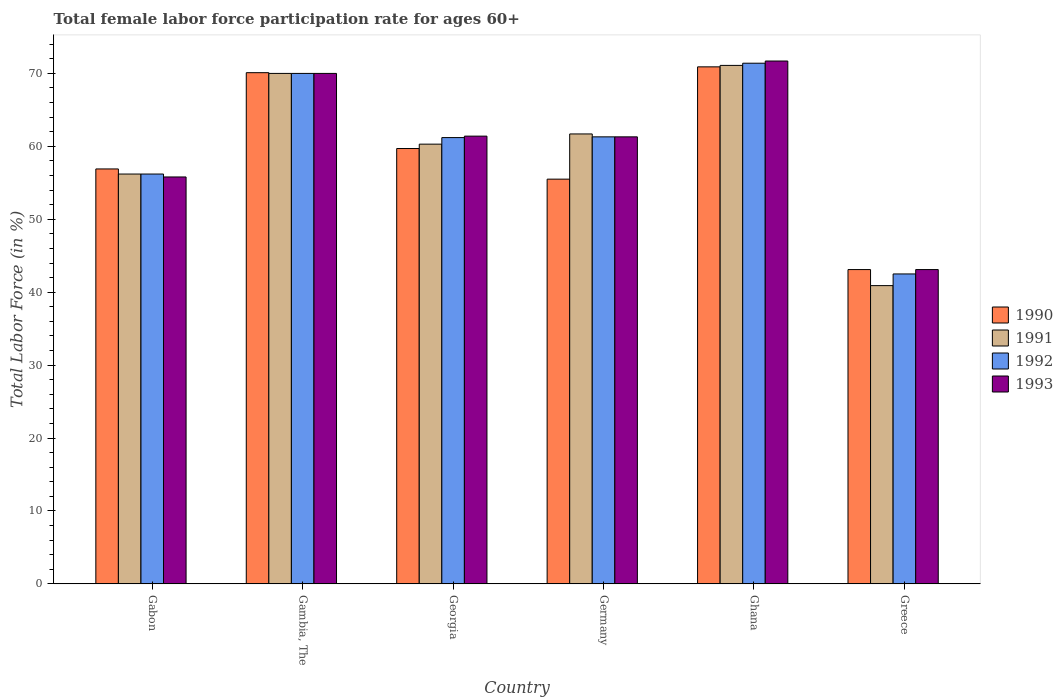How many different coloured bars are there?
Ensure brevity in your answer.  4. How many groups of bars are there?
Offer a very short reply. 6. How many bars are there on the 5th tick from the right?
Your answer should be compact. 4. What is the label of the 3rd group of bars from the left?
Your answer should be very brief. Georgia. In how many cases, is the number of bars for a given country not equal to the number of legend labels?
Your answer should be compact. 0. What is the female labor force participation rate in 1992 in Greece?
Make the answer very short. 42.5. Across all countries, what is the maximum female labor force participation rate in 1992?
Your answer should be compact. 71.4. Across all countries, what is the minimum female labor force participation rate in 1993?
Offer a terse response. 43.1. In which country was the female labor force participation rate in 1991 maximum?
Make the answer very short. Ghana. What is the total female labor force participation rate in 1991 in the graph?
Your answer should be compact. 360.2. What is the difference between the female labor force participation rate in 1993 in Gambia, The and that in Ghana?
Offer a very short reply. -1.7. What is the difference between the female labor force participation rate in 1992 in Germany and the female labor force participation rate in 1990 in Greece?
Your answer should be compact. 18.2. What is the average female labor force participation rate in 1990 per country?
Your response must be concise. 59.37. What is the difference between the female labor force participation rate of/in 1993 and female labor force participation rate of/in 1990 in Germany?
Your answer should be very brief. 5.8. What is the ratio of the female labor force participation rate in 1990 in Germany to that in Greece?
Provide a succinct answer. 1.29. Is the female labor force participation rate in 1990 in Georgia less than that in Greece?
Your answer should be compact. No. Is the difference between the female labor force participation rate in 1993 in Georgia and Greece greater than the difference between the female labor force participation rate in 1990 in Georgia and Greece?
Give a very brief answer. Yes. What is the difference between the highest and the second highest female labor force participation rate in 1991?
Provide a succinct answer. -8.3. What is the difference between the highest and the lowest female labor force participation rate in 1991?
Offer a very short reply. 30.2. Is the sum of the female labor force participation rate in 1993 in Gabon and Gambia, The greater than the maximum female labor force participation rate in 1990 across all countries?
Your answer should be compact. Yes. Is it the case that in every country, the sum of the female labor force participation rate in 1990 and female labor force participation rate in 1993 is greater than the sum of female labor force participation rate in 1992 and female labor force participation rate in 1991?
Provide a succinct answer. No. What does the 4th bar from the right in Gambia, The represents?
Keep it short and to the point. 1990. Is it the case that in every country, the sum of the female labor force participation rate in 1991 and female labor force participation rate in 1993 is greater than the female labor force participation rate in 1992?
Offer a terse response. Yes. What is the difference between two consecutive major ticks on the Y-axis?
Keep it short and to the point. 10. Does the graph contain grids?
Make the answer very short. No. Where does the legend appear in the graph?
Your answer should be very brief. Center right. What is the title of the graph?
Offer a terse response. Total female labor force participation rate for ages 60+. Does "2008" appear as one of the legend labels in the graph?
Your response must be concise. No. What is the label or title of the X-axis?
Keep it short and to the point. Country. What is the label or title of the Y-axis?
Give a very brief answer. Total Labor Force (in %). What is the Total Labor Force (in %) in 1990 in Gabon?
Keep it short and to the point. 56.9. What is the Total Labor Force (in %) in 1991 in Gabon?
Provide a succinct answer. 56.2. What is the Total Labor Force (in %) in 1992 in Gabon?
Offer a terse response. 56.2. What is the Total Labor Force (in %) in 1993 in Gabon?
Your response must be concise. 55.8. What is the Total Labor Force (in %) in 1990 in Gambia, The?
Ensure brevity in your answer.  70.1. What is the Total Labor Force (in %) of 1992 in Gambia, The?
Ensure brevity in your answer.  70. What is the Total Labor Force (in %) of 1990 in Georgia?
Your answer should be compact. 59.7. What is the Total Labor Force (in %) of 1991 in Georgia?
Your answer should be compact. 60.3. What is the Total Labor Force (in %) of 1992 in Georgia?
Your answer should be very brief. 61.2. What is the Total Labor Force (in %) of 1993 in Georgia?
Keep it short and to the point. 61.4. What is the Total Labor Force (in %) in 1990 in Germany?
Provide a succinct answer. 55.5. What is the Total Labor Force (in %) of 1991 in Germany?
Your answer should be very brief. 61.7. What is the Total Labor Force (in %) in 1992 in Germany?
Ensure brevity in your answer.  61.3. What is the Total Labor Force (in %) in 1993 in Germany?
Make the answer very short. 61.3. What is the Total Labor Force (in %) in 1990 in Ghana?
Provide a short and direct response. 70.9. What is the Total Labor Force (in %) in 1991 in Ghana?
Your response must be concise. 71.1. What is the Total Labor Force (in %) in 1992 in Ghana?
Keep it short and to the point. 71.4. What is the Total Labor Force (in %) in 1993 in Ghana?
Your answer should be compact. 71.7. What is the Total Labor Force (in %) in 1990 in Greece?
Offer a terse response. 43.1. What is the Total Labor Force (in %) of 1991 in Greece?
Your answer should be compact. 40.9. What is the Total Labor Force (in %) in 1992 in Greece?
Your answer should be very brief. 42.5. What is the Total Labor Force (in %) of 1993 in Greece?
Your response must be concise. 43.1. Across all countries, what is the maximum Total Labor Force (in %) of 1990?
Your answer should be compact. 70.9. Across all countries, what is the maximum Total Labor Force (in %) in 1991?
Your response must be concise. 71.1. Across all countries, what is the maximum Total Labor Force (in %) of 1992?
Keep it short and to the point. 71.4. Across all countries, what is the maximum Total Labor Force (in %) of 1993?
Give a very brief answer. 71.7. Across all countries, what is the minimum Total Labor Force (in %) of 1990?
Your answer should be very brief. 43.1. Across all countries, what is the minimum Total Labor Force (in %) in 1991?
Your answer should be compact. 40.9. Across all countries, what is the minimum Total Labor Force (in %) of 1992?
Provide a short and direct response. 42.5. Across all countries, what is the minimum Total Labor Force (in %) in 1993?
Offer a very short reply. 43.1. What is the total Total Labor Force (in %) of 1990 in the graph?
Make the answer very short. 356.2. What is the total Total Labor Force (in %) of 1991 in the graph?
Offer a very short reply. 360.2. What is the total Total Labor Force (in %) of 1992 in the graph?
Offer a terse response. 362.6. What is the total Total Labor Force (in %) of 1993 in the graph?
Your response must be concise. 363.3. What is the difference between the Total Labor Force (in %) in 1991 in Gabon and that in Georgia?
Keep it short and to the point. -4.1. What is the difference between the Total Labor Force (in %) in 1992 in Gabon and that in Georgia?
Provide a succinct answer. -5. What is the difference between the Total Labor Force (in %) in 1993 in Gabon and that in Georgia?
Make the answer very short. -5.6. What is the difference between the Total Labor Force (in %) of 1990 in Gabon and that in Ghana?
Your answer should be very brief. -14. What is the difference between the Total Labor Force (in %) of 1991 in Gabon and that in Ghana?
Provide a succinct answer. -14.9. What is the difference between the Total Labor Force (in %) of 1992 in Gabon and that in Ghana?
Your answer should be compact. -15.2. What is the difference between the Total Labor Force (in %) in 1993 in Gabon and that in Ghana?
Give a very brief answer. -15.9. What is the difference between the Total Labor Force (in %) of 1991 in Gabon and that in Greece?
Make the answer very short. 15.3. What is the difference between the Total Labor Force (in %) of 1993 in Gabon and that in Greece?
Your answer should be compact. 12.7. What is the difference between the Total Labor Force (in %) in 1990 in Gambia, The and that in Georgia?
Ensure brevity in your answer.  10.4. What is the difference between the Total Labor Force (in %) of 1991 in Gambia, The and that in Georgia?
Your answer should be compact. 9.7. What is the difference between the Total Labor Force (in %) in 1993 in Gambia, The and that in Georgia?
Offer a terse response. 8.6. What is the difference between the Total Labor Force (in %) of 1990 in Gambia, The and that in Germany?
Your answer should be compact. 14.6. What is the difference between the Total Labor Force (in %) in 1991 in Gambia, The and that in Germany?
Make the answer very short. 8.3. What is the difference between the Total Labor Force (in %) in 1992 in Gambia, The and that in Germany?
Make the answer very short. 8.7. What is the difference between the Total Labor Force (in %) of 1993 in Gambia, The and that in Germany?
Ensure brevity in your answer.  8.7. What is the difference between the Total Labor Force (in %) in 1990 in Gambia, The and that in Ghana?
Your answer should be very brief. -0.8. What is the difference between the Total Labor Force (in %) in 1992 in Gambia, The and that in Ghana?
Offer a very short reply. -1.4. What is the difference between the Total Labor Force (in %) of 1990 in Gambia, The and that in Greece?
Make the answer very short. 27. What is the difference between the Total Labor Force (in %) in 1991 in Gambia, The and that in Greece?
Keep it short and to the point. 29.1. What is the difference between the Total Labor Force (in %) in 1992 in Gambia, The and that in Greece?
Your response must be concise. 27.5. What is the difference between the Total Labor Force (in %) in 1993 in Gambia, The and that in Greece?
Keep it short and to the point. 26.9. What is the difference between the Total Labor Force (in %) in 1992 in Georgia and that in Germany?
Keep it short and to the point. -0.1. What is the difference between the Total Labor Force (in %) in 1990 in Georgia and that in Ghana?
Ensure brevity in your answer.  -11.2. What is the difference between the Total Labor Force (in %) of 1993 in Georgia and that in Ghana?
Provide a succinct answer. -10.3. What is the difference between the Total Labor Force (in %) of 1990 in Georgia and that in Greece?
Ensure brevity in your answer.  16.6. What is the difference between the Total Labor Force (in %) in 1992 in Georgia and that in Greece?
Your answer should be compact. 18.7. What is the difference between the Total Labor Force (in %) in 1993 in Georgia and that in Greece?
Give a very brief answer. 18.3. What is the difference between the Total Labor Force (in %) in 1990 in Germany and that in Ghana?
Provide a short and direct response. -15.4. What is the difference between the Total Labor Force (in %) of 1991 in Germany and that in Ghana?
Offer a very short reply. -9.4. What is the difference between the Total Labor Force (in %) in 1993 in Germany and that in Ghana?
Your answer should be very brief. -10.4. What is the difference between the Total Labor Force (in %) of 1991 in Germany and that in Greece?
Make the answer very short. 20.8. What is the difference between the Total Labor Force (in %) in 1992 in Germany and that in Greece?
Make the answer very short. 18.8. What is the difference between the Total Labor Force (in %) of 1990 in Ghana and that in Greece?
Ensure brevity in your answer.  27.8. What is the difference between the Total Labor Force (in %) in 1991 in Ghana and that in Greece?
Make the answer very short. 30.2. What is the difference between the Total Labor Force (in %) of 1992 in Ghana and that in Greece?
Provide a short and direct response. 28.9. What is the difference between the Total Labor Force (in %) in 1993 in Ghana and that in Greece?
Your answer should be compact. 28.6. What is the difference between the Total Labor Force (in %) of 1990 in Gabon and the Total Labor Force (in %) of 1991 in Gambia, The?
Keep it short and to the point. -13.1. What is the difference between the Total Labor Force (in %) of 1990 in Gabon and the Total Labor Force (in %) of 1992 in Gambia, The?
Your answer should be very brief. -13.1. What is the difference between the Total Labor Force (in %) in 1990 in Gabon and the Total Labor Force (in %) in 1993 in Gambia, The?
Offer a terse response. -13.1. What is the difference between the Total Labor Force (in %) of 1991 in Gabon and the Total Labor Force (in %) of 1993 in Gambia, The?
Keep it short and to the point. -13.8. What is the difference between the Total Labor Force (in %) of 1990 in Gabon and the Total Labor Force (in %) of 1991 in Georgia?
Make the answer very short. -3.4. What is the difference between the Total Labor Force (in %) in 1990 in Gabon and the Total Labor Force (in %) in 1993 in Georgia?
Give a very brief answer. -4.5. What is the difference between the Total Labor Force (in %) in 1991 in Gabon and the Total Labor Force (in %) in 1992 in Georgia?
Offer a terse response. -5. What is the difference between the Total Labor Force (in %) in 1990 in Gabon and the Total Labor Force (in %) in 1992 in Germany?
Your answer should be very brief. -4.4. What is the difference between the Total Labor Force (in %) of 1991 in Gabon and the Total Labor Force (in %) of 1992 in Germany?
Offer a very short reply. -5.1. What is the difference between the Total Labor Force (in %) of 1991 in Gabon and the Total Labor Force (in %) of 1993 in Germany?
Offer a terse response. -5.1. What is the difference between the Total Labor Force (in %) in 1992 in Gabon and the Total Labor Force (in %) in 1993 in Germany?
Provide a short and direct response. -5.1. What is the difference between the Total Labor Force (in %) in 1990 in Gabon and the Total Labor Force (in %) in 1991 in Ghana?
Your answer should be compact. -14.2. What is the difference between the Total Labor Force (in %) of 1990 in Gabon and the Total Labor Force (in %) of 1992 in Ghana?
Your answer should be compact. -14.5. What is the difference between the Total Labor Force (in %) of 1990 in Gabon and the Total Labor Force (in %) of 1993 in Ghana?
Ensure brevity in your answer.  -14.8. What is the difference between the Total Labor Force (in %) of 1991 in Gabon and the Total Labor Force (in %) of 1992 in Ghana?
Ensure brevity in your answer.  -15.2. What is the difference between the Total Labor Force (in %) in 1991 in Gabon and the Total Labor Force (in %) in 1993 in Ghana?
Your answer should be very brief. -15.5. What is the difference between the Total Labor Force (in %) in 1992 in Gabon and the Total Labor Force (in %) in 1993 in Ghana?
Your answer should be compact. -15.5. What is the difference between the Total Labor Force (in %) of 1990 in Gabon and the Total Labor Force (in %) of 1991 in Greece?
Keep it short and to the point. 16. What is the difference between the Total Labor Force (in %) of 1990 in Gabon and the Total Labor Force (in %) of 1993 in Greece?
Your answer should be very brief. 13.8. What is the difference between the Total Labor Force (in %) in 1991 in Gabon and the Total Labor Force (in %) in 1992 in Greece?
Provide a succinct answer. 13.7. What is the difference between the Total Labor Force (in %) in 1991 in Gabon and the Total Labor Force (in %) in 1993 in Greece?
Ensure brevity in your answer.  13.1. What is the difference between the Total Labor Force (in %) of 1992 in Gabon and the Total Labor Force (in %) of 1993 in Greece?
Give a very brief answer. 13.1. What is the difference between the Total Labor Force (in %) in 1990 in Gambia, The and the Total Labor Force (in %) in 1992 in Georgia?
Make the answer very short. 8.9. What is the difference between the Total Labor Force (in %) in 1990 in Gambia, The and the Total Labor Force (in %) in 1991 in Germany?
Your answer should be very brief. 8.4. What is the difference between the Total Labor Force (in %) in 1990 in Gambia, The and the Total Labor Force (in %) in 1991 in Ghana?
Give a very brief answer. -1. What is the difference between the Total Labor Force (in %) in 1990 in Gambia, The and the Total Labor Force (in %) in 1992 in Ghana?
Offer a terse response. -1.3. What is the difference between the Total Labor Force (in %) of 1991 in Gambia, The and the Total Labor Force (in %) of 1992 in Ghana?
Keep it short and to the point. -1.4. What is the difference between the Total Labor Force (in %) in 1992 in Gambia, The and the Total Labor Force (in %) in 1993 in Ghana?
Ensure brevity in your answer.  -1.7. What is the difference between the Total Labor Force (in %) of 1990 in Gambia, The and the Total Labor Force (in %) of 1991 in Greece?
Offer a terse response. 29.2. What is the difference between the Total Labor Force (in %) in 1990 in Gambia, The and the Total Labor Force (in %) in 1992 in Greece?
Ensure brevity in your answer.  27.6. What is the difference between the Total Labor Force (in %) in 1991 in Gambia, The and the Total Labor Force (in %) in 1992 in Greece?
Provide a short and direct response. 27.5. What is the difference between the Total Labor Force (in %) of 1991 in Gambia, The and the Total Labor Force (in %) of 1993 in Greece?
Your answer should be compact. 26.9. What is the difference between the Total Labor Force (in %) in 1992 in Gambia, The and the Total Labor Force (in %) in 1993 in Greece?
Provide a succinct answer. 26.9. What is the difference between the Total Labor Force (in %) of 1990 in Georgia and the Total Labor Force (in %) of 1992 in Germany?
Keep it short and to the point. -1.6. What is the difference between the Total Labor Force (in %) in 1990 in Georgia and the Total Labor Force (in %) in 1992 in Ghana?
Make the answer very short. -11.7. What is the difference between the Total Labor Force (in %) in 1990 in Georgia and the Total Labor Force (in %) in 1992 in Greece?
Your answer should be compact. 17.2. What is the difference between the Total Labor Force (in %) in 1991 in Georgia and the Total Labor Force (in %) in 1993 in Greece?
Make the answer very short. 17.2. What is the difference between the Total Labor Force (in %) of 1992 in Georgia and the Total Labor Force (in %) of 1993 in Greece?
Make the answer very short. 18.1. What is the difference between the Total Labor Force (in %) of 1990 in Germany and the Total Labor Force (in %) of 1991 in Ghana?
Your answer should be compact. -15.6. What is the difference between the Total Labor Force (in %) of 1990 in Germany and the Total Labor Force (in %) of 1992 in Ghana?
Make the answer very short. -15.9. What is the difference between the Total Labor Force (in %) of 1990 in Germany and the Total Labor Force (in %) of 1993 in Ghana?
Give a very brief answer. -16.2. What is the difference between the Total Labor Force (in %) of 1991 in Germany and the Total Labor Force (in %) of 1992 in Ghana?
Keep it short and to the point. -9.7. What is the difference between the Total Labor Force (in %) in 1990 in Germany and the Total Labor Force (in %) in 1991 in Greece?
Keep it short and to the point. 14.6. What is the difference between the Total Labor Force (in %) in 1990 in Germany and the Total Labor Force (in %) in 1993 in Greece?
Provide a short and direct response. 12.4. What is the difference between the Total Labor Force (in %) in 1990 in Ghana and the Total Labor Force (in %) in 1991 in Greece?
Ensure brevity in your answer.  30. What is the difference between the Total Labor Force (in %) in 1990 in Ghana and the Total Labor Force (in %) in 1992 in Greece?
Your answer should be compact. 28.4. What is the difference between the Total Labor Force (in %) of 1990 in Ghana and the Total Labor Force (in %) of 1993 in Greece?
Provide a short and direct response. 27.8. What is the difference between the Total Labor Force (in %) of 1991 in Ghana and the Total Labor Force (in %) of 1992 in Greece?
Make the answer very short. 28.6. What is the difference between the Total Labor Force (in %) of 1991 in Ghana and the Total Labor Force (in %) of 1993 in Greece?
Give a very brief answer. 28. What is the difference between the Total Labor Force (in %) in 1992 in Ghana and the Total Labor Force (in %) in 1993 in Greece?
Offer a very short reply. 28.3. What is the average Total Labor Force (in %) of 1990 per country?
Offer a very short reply. 59.37. What is the average Total Labor Force (in %) of 1991 per country?
Give a very brief answer. 60.03. What is the average Total Labor Force (in %) of 1992 per country?
Ensure brevity in your answer.  60.43. What is the average Total Labor Force (in %) of 1993 per country?
Provide a short and direct response. 60.55. What is the difference between the Total Labor Force (in %) in 1992 and Total Labor Force (in %) in 1993 in Gabon?
Your answer should be very brief. 0.4. What is the difference between the Total Labor Force (in %) of 1990 and Total Labor Force (in %) of 1991 in Gambia, The?
Offer a very short reply. 0.1. What is the difference between the Total Labor Force (in %) in 1991 and Total Labor Force (in %) in 1993 in Gambia, The?
Your response must be concise. 0. What is the difference between the Total Labor Force (in %) of 1990 and Total Labor Force (in %) of 1992 in Georgia?
Provide a succinct answer. -1.5. What is the difference between the Total Labor Force (in %) in 1990 and Total Labor Force (in %) in 1993 in Georgia?
Your response must be concise. -1.7. What is the difference between the Total Labor Force (in %) of 1991 and Total Labor Force (in %) of 1993 in Germany?
Make the answer very short. 0.4. What is the difference between the Total Labor Force (in %) in 1990 and Total Labor Force (in %) in 1991 in Ghana?
Offer a very short reply. -0.2. What is the difference between the Total Labor Force (in %) of 1990 and Total Labor Force (in %) of 1992 in Ghana?
Make the answer very short. -0.5. What is the difference between the Total Labor Force (in %) in 1990 and Total Labor Force (in %) in 1993 in Ghana?
Make the answer very short. -0.8. What is the difference between the Total Labor Force (in %) in 1991 and Total Labor Force (in %) in 1992 in Ghana?
Offer a terse response. -0.3. What is the difference between the Total Labor Force (in %) of 1992 and Total Labor Force (in %) of 1993 in Ghana?
Your response must be concise. -0.3. What is the difference between the Total Labor Force (in %) of 1990 and Total Labor Force (in %) of 1991 in Greece?
Ensure brevity in your answer.  2.2. What is the difference between the Total Labor Force (in %) in 1990 and Total Labor Force (in %) in 1992 in Greece?
Provide a short and direct response. 0.6. What is the difference between the Total Labor Force (in %) in 1990 and Total Labor Force (in %) in 1993 in Greece?
Make the answer very short. 0. What is the difference between the Total Labor Force (in %) of 1991 and Total Labor Force (in %) of 1992 in Greece?
Your answer should be compact. -1.6. What is the difference between the Total Labor Force (in %) in 1992 and Total Labor Force (in %) in 1993 in Greece?
Offer a terse response. -0.6. What is the ratio of the Total Labor Force (in %) of 1990 in Gabon to that in Gambia, The?
Your answer should be compact. 0.81. What is the ratio of the Total Labor Force (in %) of 1991 in Gabon to that in Gambia, The?
Offer a terse response. 0.8. What is the ratio of the Total Labor Force (in %) of 1992 in Gabon to that in Gambia, The?
Keep it short and to the point. 0.8. What is the ratio of the Total Labor Force (in %) in 1993 in Gabon to that in Gambia, The?
Your response must be concise. 0.8. What is the ratio of the Total Labor Force (in %) in 1990 in Gabon to that in Georgia?
Keep it short and to the point. 0.95. What is the ratio of the Total Labor Force (in %) in 1991 in Gabon to that in Georgia?
Offer a very short reply. 0.93. What is the ratio of the Total Labor Force (in %) of 1992 in Gabon to that in Georgia?
Keep it short and to the point. 0.92. What is the ratio of the Total Labor Force (in %) of 1993 in Gabon to that in Georgia?
Your answer should be compact. 0.91. What is the ratio of the Total Labor Force (in %) in 1990 in Gabon to that in Germany?
Your response must be concise. 1.03. What is the ratio of the Total Labor Force (in %) in 1991 in Gabon to that in Germany?
Offer a terse response. 0.91. What is the ratio of the Total Labor Force (in %) of 1992 in Gabon to that in Germany?
Offer a very short reply. 0.92. What is the ratio of the Total Labor Force (in %) in 1993 in Gabon to that in Germany?
Offer a very short reply. 0.91. What is the ratio of the Total Labor Force (in %) of 1990 in Gabon to that in Ghana?
Make the answer very short. 0.8. What is the ratio of the Total Labor Force (in %) of 1991 in Gabon to that in Ghana?
Your answer should be compact. 0.79. What is the ratio of the Total Labor Force (in %) of 1992 in Gabon to that in Ghana?
Provide a short and direct response. 0.79. What is the ratio of the Total Labor Force (in %) of 1993 in Gabon to that in Ghana?
Ensure brevity in your answer.  0.78. What is the ratio of the Total Labor Force (in %) in 1990 in Gabon to that in Greece?
Give a very brief answer. 1.32. What is the ratio of the Total Labor Force (in %) of 1991 in Gabon to that in Greece?
Offer a terse response. 1.37. What is the ratio of the Total Labor Force (in %) of 1992 in Gabon to that in Greece?
Your response must be concise. 1.32. What is the ratio of the Total Labor Force (in %) in 1993 in Gabon to that in Greece?
Offer a very short reply. 1.29. What is the ratio of the Total Labor Force (in %) in 1990 in Gambia, The to that in Georgia?
Your answer should be very brief. 1.17. What is the ratio of the Total Labor Force (in %) of 1991 in Gambia, The to that in Georgia?
Make the answer very short. 1.16. What is the ratio of the Total Labor Force (in %) in 1992 in Gambia, The to that in Georgia?
Your answer should be very brief. 1.14. What is the ratio of the Total Labor Force (in %) of 1993 in Gambia, The to that in Georgia?
Offer a very short reply. 1.14. What is the ratio of the Total Labor Force (in %) of 1990 in Gambia, The to that in Germany?
Ensure brevity in your answer.  1.26. What is the ratio of the Total Labor Force (in %) in 1991 in Gambia, The to that in Germany?
Your response must be concise. 1.13. What is the ratio of the Total Labor Force (in %) of 1992 in Gambia, The to that in Germany?
Make the answer very short. 1.14. What is the ratio of the Total Labor Force (in %) of 1993 in Gambia, The to that in Germany?
Your answer should be very brief. 1.14. What is the ratio of the Total Labor Force (in %) in 1990 in Gambia, The to that in Ghana?
Ensure brevity in your answer.  0.99. What is the ratio of the Total Labor Force (in %) of 1991 in Gambia, The to that in Ghana?
Offer a terse response. 0.98. What is the ratio of the Total Labor Force (in %) in 1992 in Gambia, The to that in Ghana?
Your answer should be compact. 0.98. What is the ratio of the Total Labor Force (in %) in 1993 in Gambia, The to that in Ghana?
Offer a terse response. 0.98. What is the ratio of the Total Labor Force (in %) of 1990 in Gambia, The to that in Greece?
Provide a short and direct response. 1.63. What is the ratio of the Total Labor Force (in %) of 1991 in Gambia, The to that in Greece?
Offer a very short reply. 1.71. What is the ratio of the Total Labor Force (in %) in 1992 in Gambia, The to that in Greece?
Your answer should be very brief. 1.65. What is the ratio of the Total Labor Force (in %) of 1993 in Gambia, The to that in Greece?
Provide a succinct answer. 1.62. What is the ratio of the Total Labor Force (in %) of 1990 in Georgia to that in Germany?
Provide a short and direct response. 1.08. What is the ratio of the Total Labor Force (in %) in 1991 in Georgia to that in Germany?
Your answer should be very brief. 0.98. What is the ratio of the Total Labor Force (in %) of 1992 in Georgia to that in Germany?
Make the answer very short. 1. What is the ratio of the Total Labor Force (in %) of 1990 in Georgia to that in Ghana?
Keep it short and to the point. 0.84. What is the ratio of the Total Labor Force (in %) in 1991 in Georgia to that in Ghana?
Ensure brevity in your answer.  0.85. What is the ratio of the Total Labor Force (in %) in 1993 in Georgia to that in Ghana?
Your response must be concise. 0.86. What is the ratio of the Total Labor Force (in %) in 1990 in Georgia to that in Greece?
Your answer should be compact. 1.39. What is the ratio of the Total Labor Force (in %) of 1991 in Georgia to that in Greece?
Provide a succinct answer. 1.47. What is the ratio of the Total Labor Force (in %) in 1992 in Georgia to that in Greece?
Make the answer very short. 1.44. What is the ratio of the Total Labor Force (in %) of 1993 in Georgia to that in Greece?
Your response must be concise. 1.42. What is the ratio of the Total Labor Force (in %) of 1990 in Germany to that in Ghana?
Give a very brief answer. 0.78. What is the ratio of the Total Labor Force (in %) of 1991 in Germany to that in Ghana?
Your response must be concise. 0.87. What is the ratio of the Total Labor Force (in %) in 1992 in Germany to that in Ghana?
Offer a very short reply. 0.86. What is the ratio of the Total Labor Force (in %) in 1993 in Germany to that in Ghana?
Provide a short and direct response. 0.85. What is the ratio of the Total Labor Force (in %) in 1990 in Germany to that in Greece?
Give a very brief answer. 1.29. What is the ratio of the Total Labor Force (in %) of 1991 in Germany to that in Greece?
Your answer should be compact. 1.51. What is the ratio of the Total Labor Force (in %) of 1992 in Germany to that in Greece?
Offer a terse response. 1.44. What is the ratio of the Total Labor Force (in %) in 1993 in Germany to that in Greece?
Give a very brief answer. 1.42. What is the ratio of the Total Labor Force (in %) of 1990 in Ghana to that in Greece?
Your answer should be very brief. 1.65. What is the ratio of the Total Labor Force (in %) in 1991 in Ghana to that in Greece?
Your answer should be compact. 1.74. What is the ratio of the Total Labor Force (in %) in 1992 in Ghana to that in Greece?
Offer a very short reply. 1.68. What is the ratio of the Total Labor Force (in %) of 1993 in Ghana to that in Greece?
Your answer should be very brief. 1.66. What is the difference between the highest and the second highest Total Labor Force (in %) of 1991?
Offer a terse response. 1.1. What is the difference between the highest and the second highest Total Labor Force (in %) of 1992?
Provide a short and direct response. 1.4. What is the difference between the highest and the second highest Total Labor Force (in %) of 1993?
Give a very brief answer. 1.7. What is the difference between the highest and the lowest Total Labor Force (in %) in 1990?
Your answer should be compact. 27.8. What is the difference between the highest and the lowest Total Labor Force (in %) of 1991?
Ensure brevity in your answer.  30.2. What is the difference between the highest and the lowest Total Labor Force (in %) of 1992?
Offer a terse response. 28.9. What is the difference between the highest and the lowest Total Labor Force (in %) in 1993?
Make the answer very short. 28.6. 